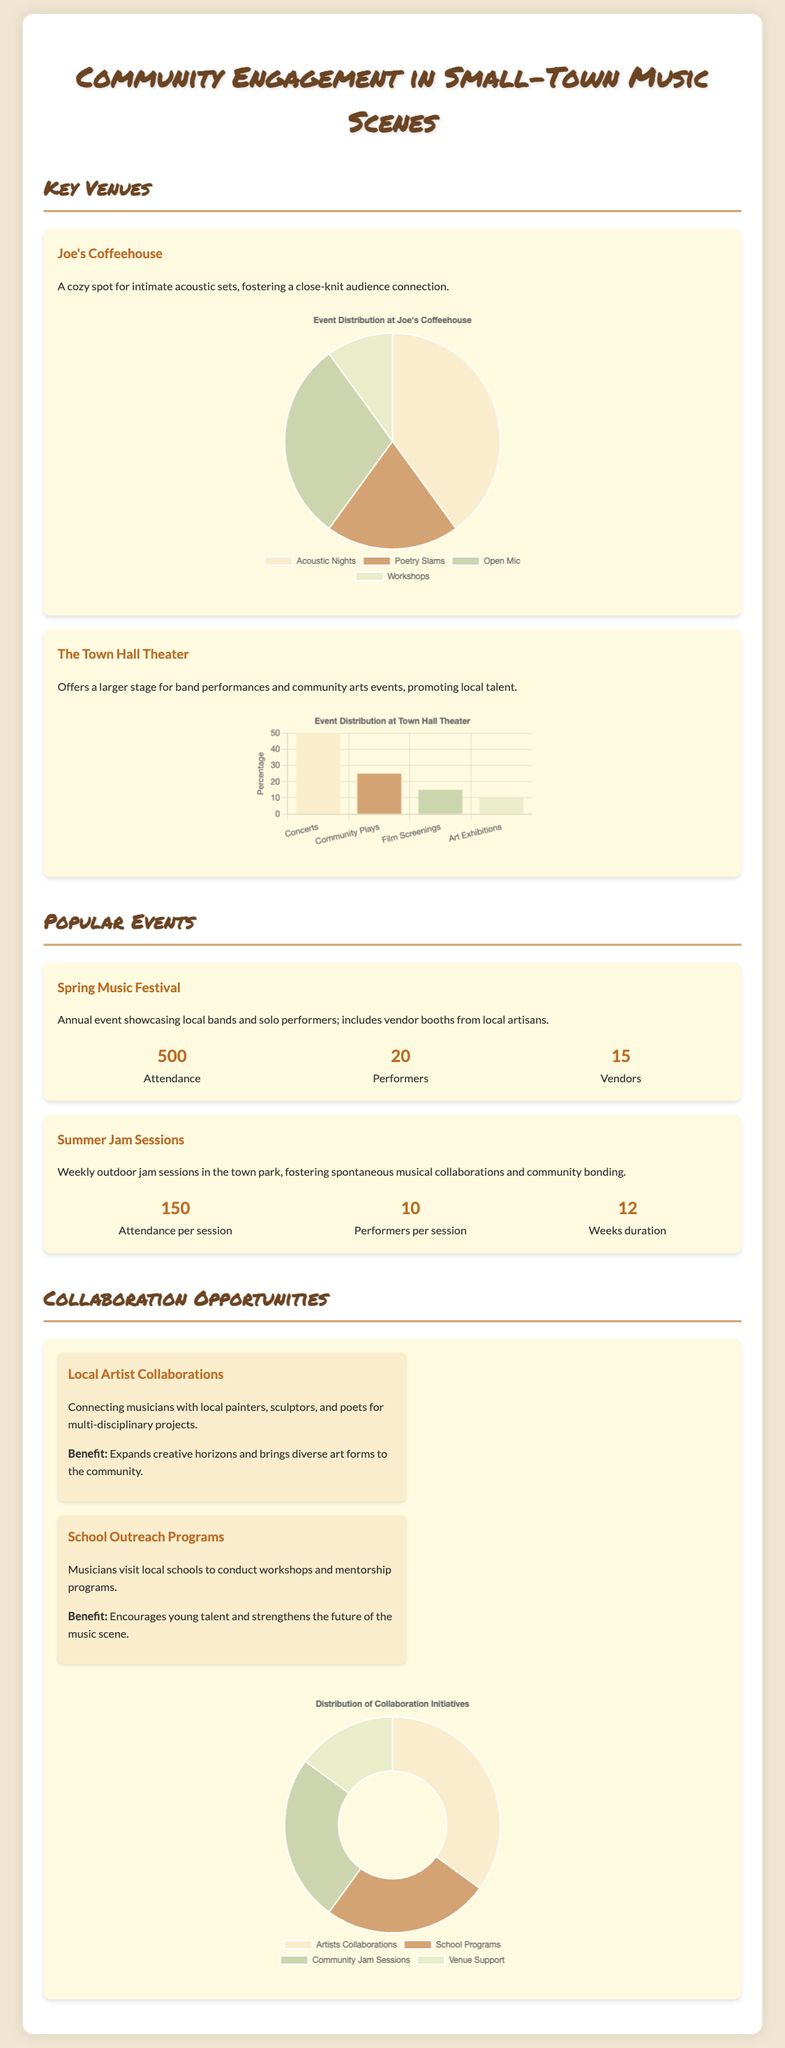What is the capacity of Joe's Coffeehouse for acoustic nights? The pie chart for Joe's Coffeehouse indicates that 40% of the events are Acoustic Nights.
Answer: 40% How many performers are there in the Spring Music Festival? The document states there are 20 performers participating in the Spring Music Festival.
Answer: 20 What type of events take place at The Town Hall Theater? The bar chart specifically lists Concerts, Community Plays, Film Screenings, and Art Exhibitions as the event types.
Answer: Concerts, Community Plays, Film Screenings, Art Exhibitions What is the average attendance per week for the Summer Jam Sessions? The document notes that the average attendance per session is 150 and lasts for 12 weeks, thus the total can be calculated; however, the average remains 150 per session.
Answer: 150 What is the focus of School Outreach Programs? The document mentions that School Outreach Programs involve musicians visiting schools for workshops and mentorship, highlighting talent encouragement.
Answer: Workshops and mentorship What percentage of collaboration initiatives are dedicated to Local Artist Collaborations? The doughnut chart indicates that 35% of the collaboration initiatives focus on Local Artist Collaborations.
Answer: 35% Which venue features intimate acoustic sets? The document describes Joe's Coffeehouse as a cozy spot for intimate acoustic sets.
Answer: Joe's Coffeehouse How many weekly sessions are held during the Summer Jam Sessions? The document states the duration of the Summer Jam Sessions is 12 weeks.
Answer: 12 What type of events are included in the Community Engagement chart? The pie chart displays Artist Collaborations, School Programs, Community Jam Sessions, and Venue Support as the types of initiatives.
Answer: Artist Collaborations, School Programs, Community Jam Sessions, Venue Support 